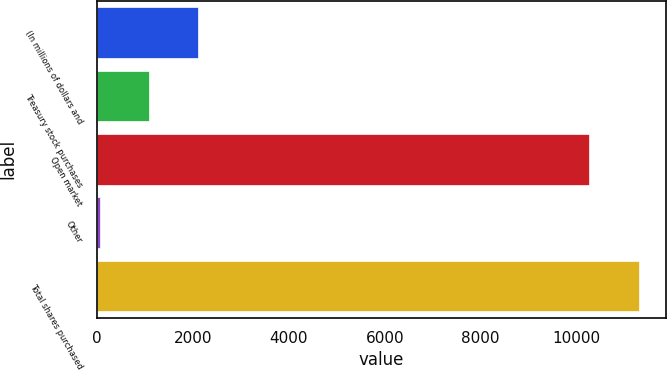<chart> <loc_0><loc_0><loc_500><loc_500><bar_chart><fcel>(In millions of dollars and<fcel>Treasury stock purchases<fcel>Open market<fcel>Other<fcel>Total shares purchased<nl><fcel>2108<fcel>1081.5<fcel>10265<fcel>55<fcel>11291.5<nl></chart> 